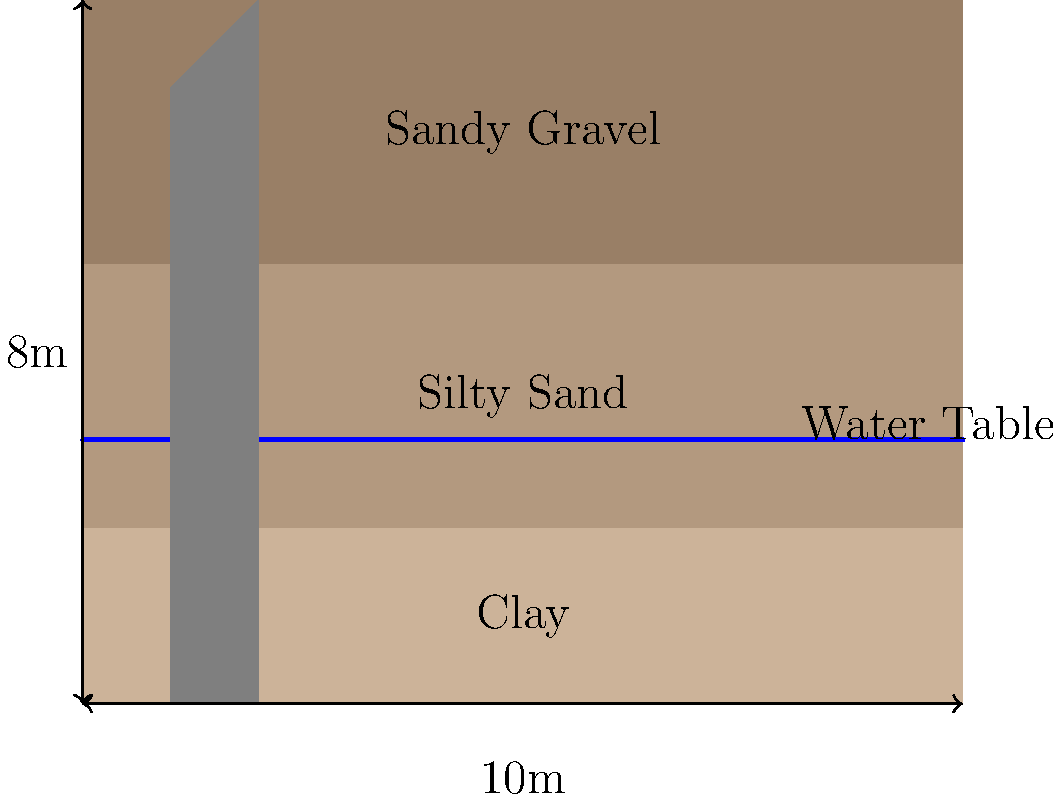Given the hillside retaining wall shown in the diagram with three distinct soil layers and a water table, determine the primary factor that could compromise the wall's stability. How might this factor be mitigated to enhance the wall's performance in the context of Puerto Rico's environmental conditions? To analyze the stability of the hillside retaining wall, we need to consider several factors:

1. Soil Layers:
   - Clay (bottom layer): Known for low permeability and potential for swelling.
   - Silty Sand (middle layer): Moderate permeability, but susceptible to erosion.
   - Sandy Gravel (top layer): High permeability, good drainage.

2. Water Table:
   The water table is located within the silty sand layer, which is a critical factor.

3. Primary Stability Concern:
   The main factor compromising the wall's stability is likely hydrostatic pressure due to the high water table. This is because:
   a) Water in the silty sand layer can create significant lateral pressure on the wall.
   b) The clay layer below may prevent proper drainage, exacerbating the problem.

4. Mitigation Strategies:
   To enhance the wall's performance, considering Puerto Rico's environmental conditions (frequent heavy rainfall, potential for hurricanes), we could:
   a) Install a proper drainage system behind the wall to lower the water table.
   b) Use geotextiles to prevent soil erosion and improve drainage.
   c) Consider soil nailing or anchoring to increase wall stability.
   d) Implement bioengineering solutions, such as planting native vegetation with strong root systems above the wall to increase soil cohesion.

5. Environmental Considerations:
   As an environmental scientist in Puerto Rico, it's important to consider:
   a) Using local, sustainable materials for drainage systems.
   b) Ensuring that any drainage solution doesn't negatively impact downstream ecosystems.
   c) Incorporating green infrastructure principles to manage stormwater runoff.

The primary factor compromising the wall's stability is the high water table creating hydrostatic pressure. Mitigating this through improved drainage, while considering local environmental factors, would significantly enhance the wall's performance.
Answer: Hydrostatic pressure from high water table; mitigate with improved drainage system and bioengineering solutions. 